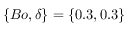<formula> <loc_0><loc_0><loc_500><loc_500>\{ B o , \delta \} = \{ 0 . 3 , 0 . 3 \}</formula> 